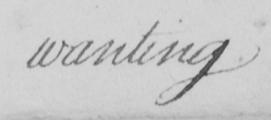Please provide the text content of this handwritten line. wanting 